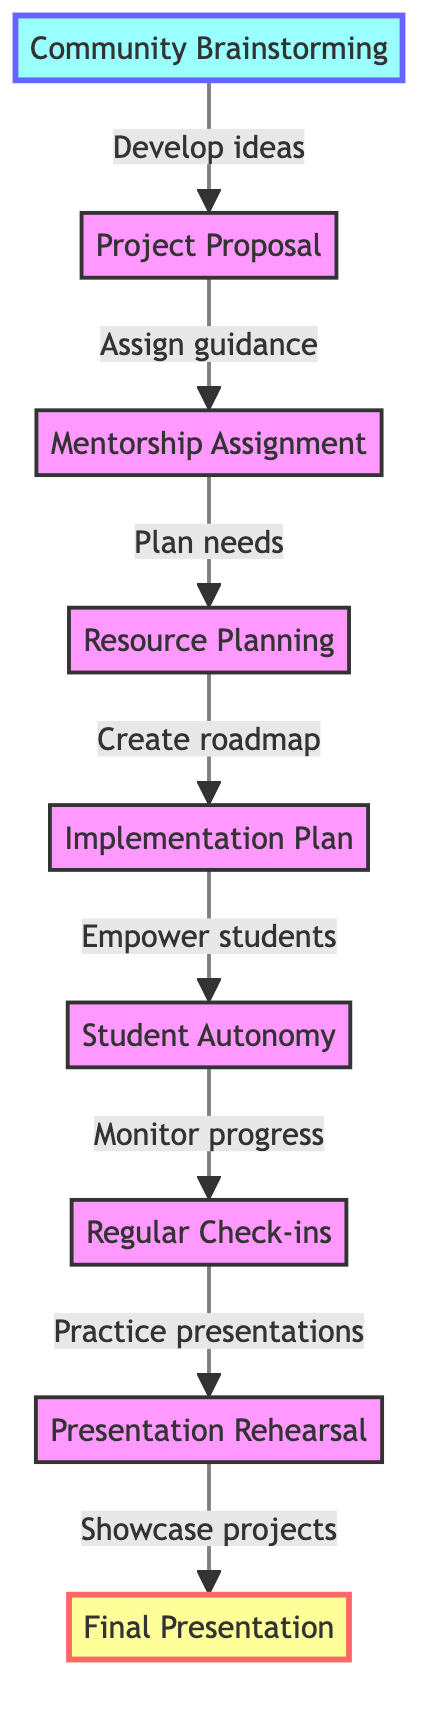What is the top node of the diagram? The top node of the diagram is the node that represents the final stage in the process. According to the diagram, this is "Final Presentation," which shows the culmination of the student-led project.
Answer: Final Presentation How many nodes are in the diagram? To find the total number of nodes, we can count each stage represented in the flowchart. There are a total of 9 nodes in the diagram.
Answer: 9 Which node immediately precedes "Regular Check-ins"? "Regular Check-ins" is positioned after "Student Autonomy" in the flow. Thus, the node that immediately precedes it is "Student Autonomy."
Answer: Student Autonomy What is the relationship between "Community Brainstorming" and "Project Proposal"? The relationship between these two nodes can be seen from the directional arrow moving upwards from "Community Brainstorming" to "Project Proposal," indicating that ideas developed in the brainstorming session lead to the drafting of proposals.
Answer: Develop ideas What is required before the "Final Presentation"? The "Final Presentation" is dependent on the completion of several previous steps. The last step that must be completed prior to it is "Presentation Rehearsal," which involves preparing for the final showcase.
Answer: Presentation Rehearsal Which node focuses on guiding student groups? The node specifically dedicated to guiding student groups from the community and school is "Mentorship Assignment." It assigns mentors who will offer support throughout the project.
Answer: Mentorship Assignment What step comes directly after "Implementation Plan"? Following the "Implementation Plan," the next step is "Student Autonomy." This indicates that after planning, students are empowered to take ownership of their projects.
Answer: Student Autonomy Which stage emphasizes resource identification? "Resource Planning" is the stage in the diagram that emphasizes identifying the required resources for the project, such as materials, technology, and space needed to carry out their project effectively.
Answer: Resource Planning What is the purpose of the "Check-ins" node? The "Regular Check-ins" node serves the purpose of monitoring progress and facilitating problem-solving as the students work on their projects. It is an essential part of ensuring that students stay aligned with their goals.
Answer: Monitor progress 